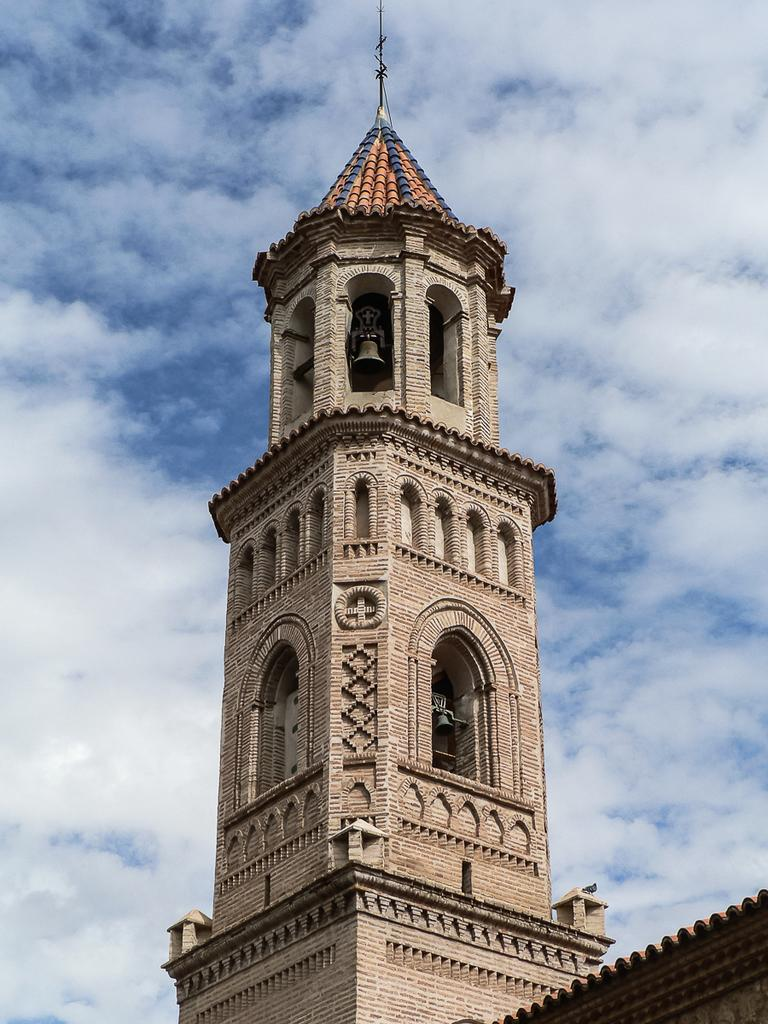What type of structure is present in the image? There is a Steeple in the image. What can be seen in the background of the image? The sky is visible in the background of the image. What is the condition of the sky in the image? There are clouds in the sky. What type of blood is visible on the Steeple in the image? There is no blood visible on the Steeple in the image. What kind of pear is hanging from the clouds in the image? There are no pears present in the image; it features a Steeple and clouds in the sky. 